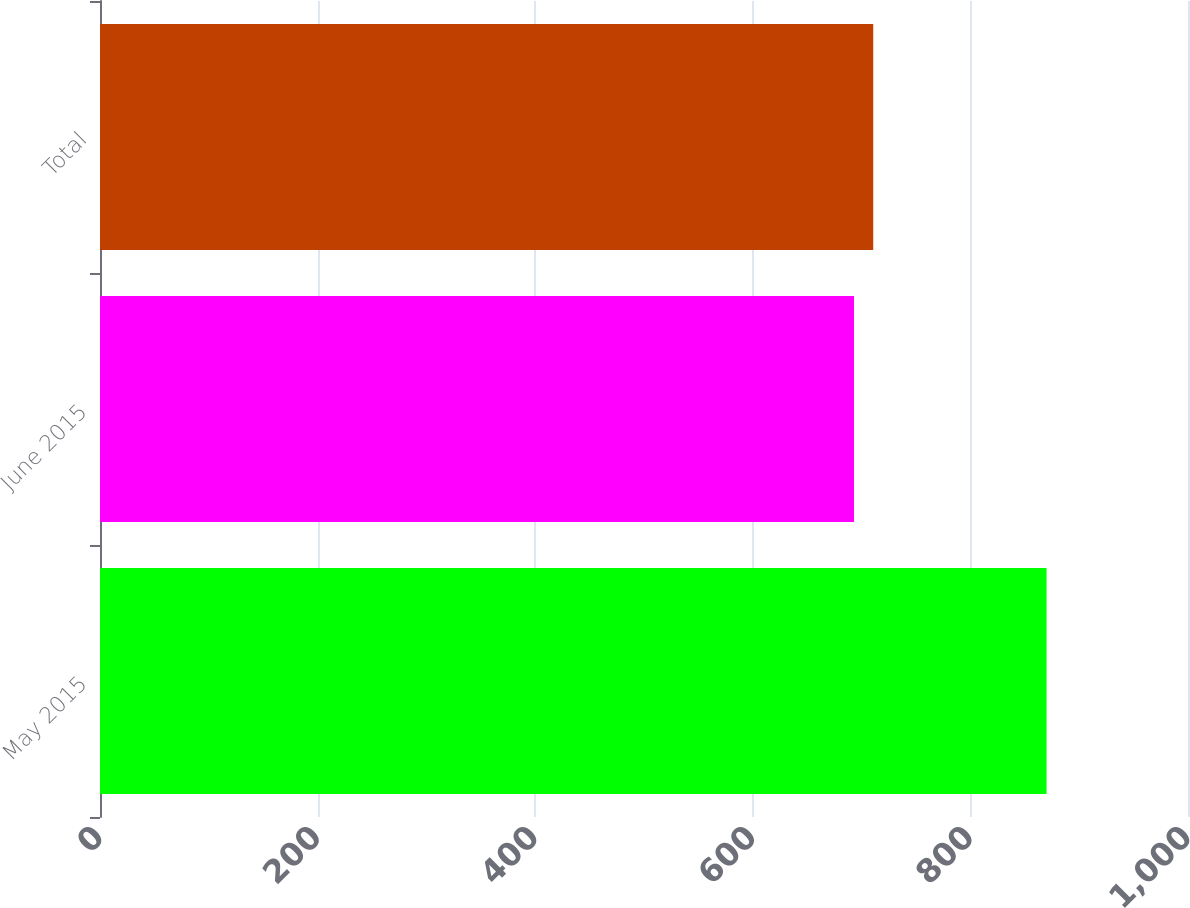Convert chart. <chart><loc_0><loc_0><loc_500><loc_500><bar_chart><fcel>May 2015<fcel>June 2015<fcel>Total<nl><fcel>870<fcel>693<fcel>710.7<nl></chart> 